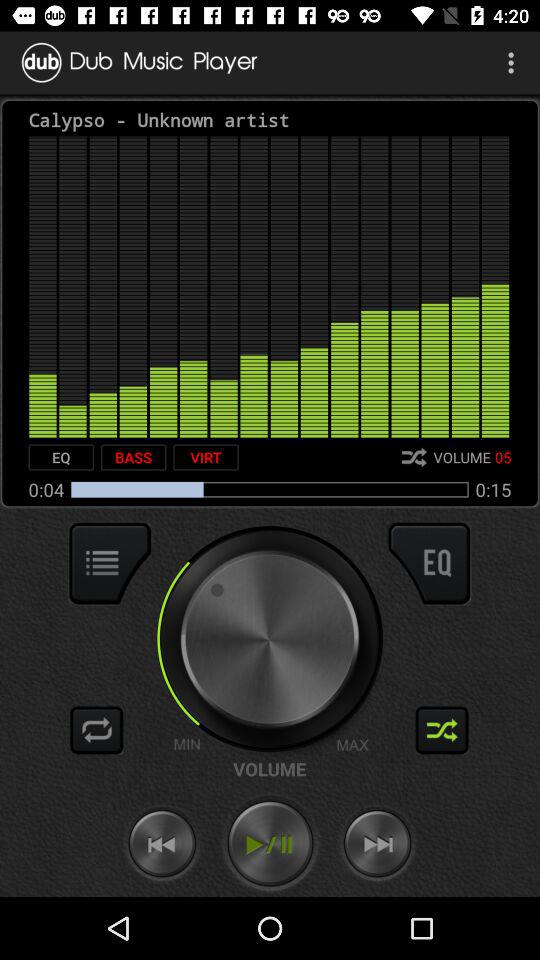What is the duration of the music? It is 15 seconds. 